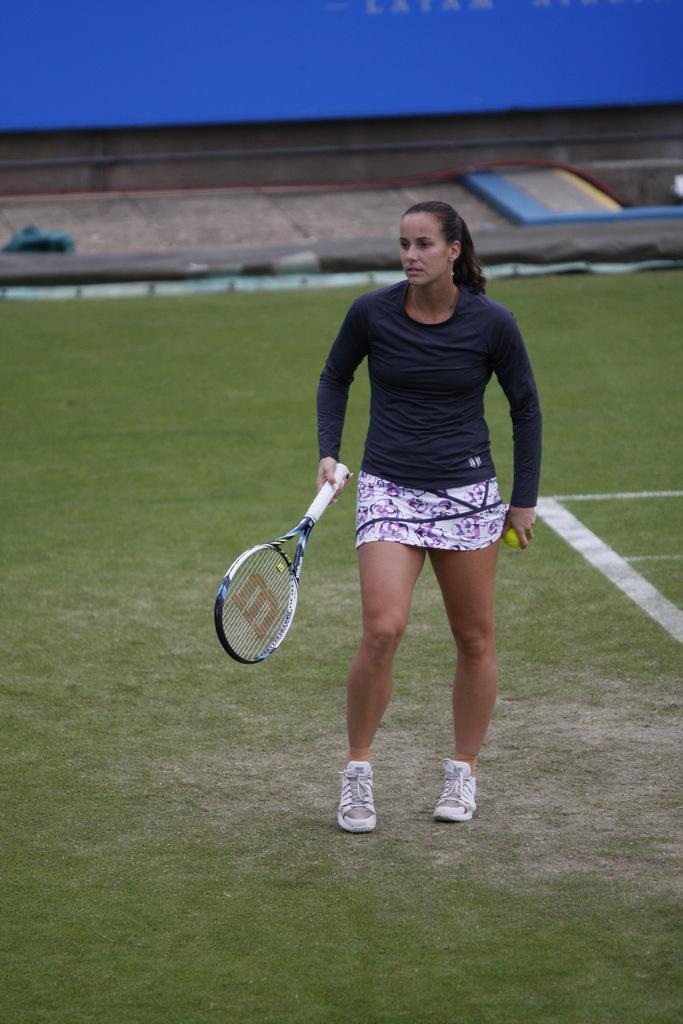Could you give a brief overview of what you see in this image? Here we can see a woman who is standing on the ground. She is holding a racket with her hand. And this is grass. 